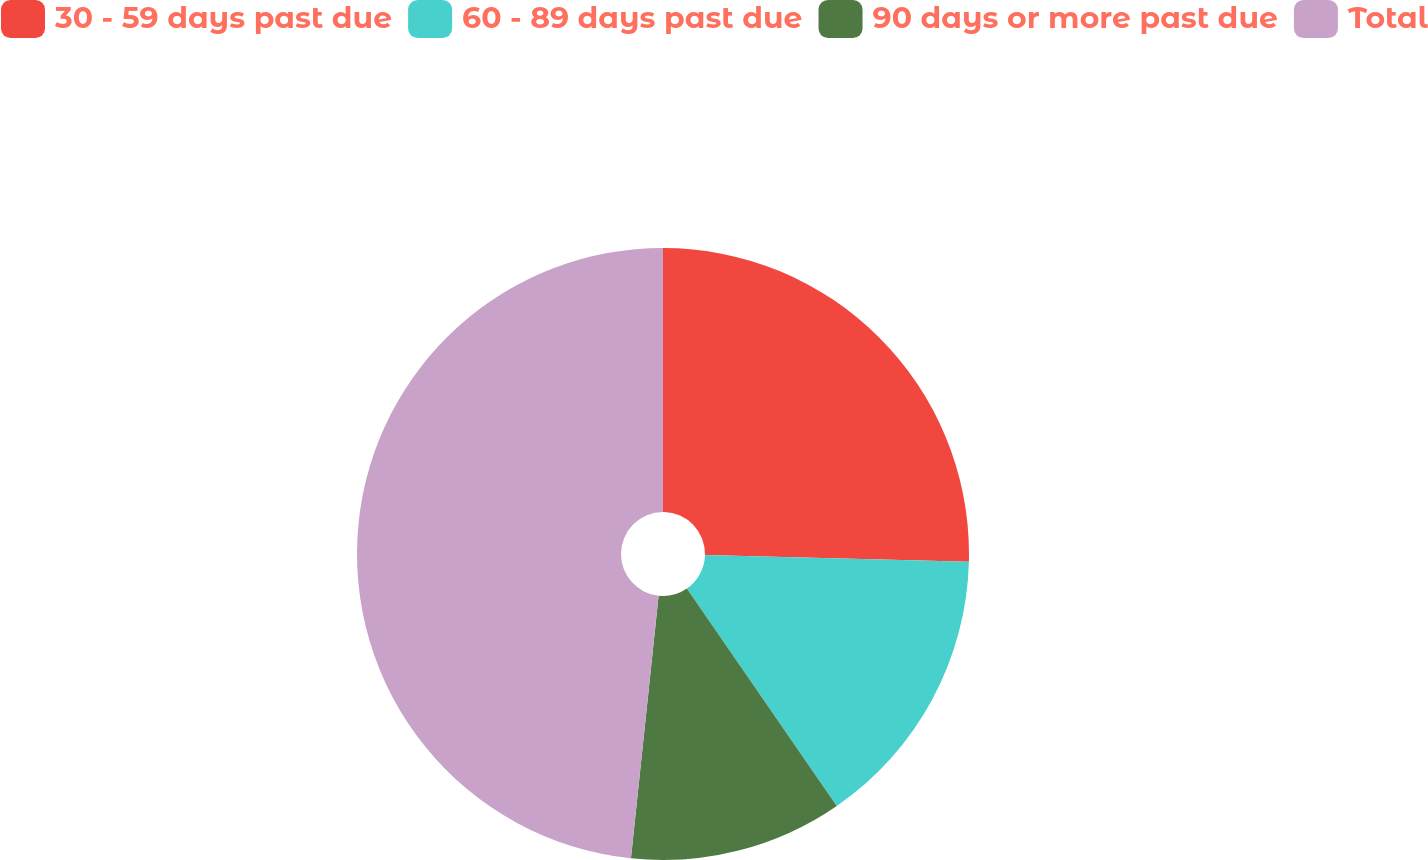Convert chart to OTSL. <chart><loc_0><loc_0><loc_500><loc_500><pie_chart><fcel>30 - 59 days past due<fcel>60 - 89 days past due<fcel>90 days or more past due<fcel>Total<nl><fcel>25.4%<fcel>14.99%<fcel>11.28%<fcel>48.33%<nl></chart> 